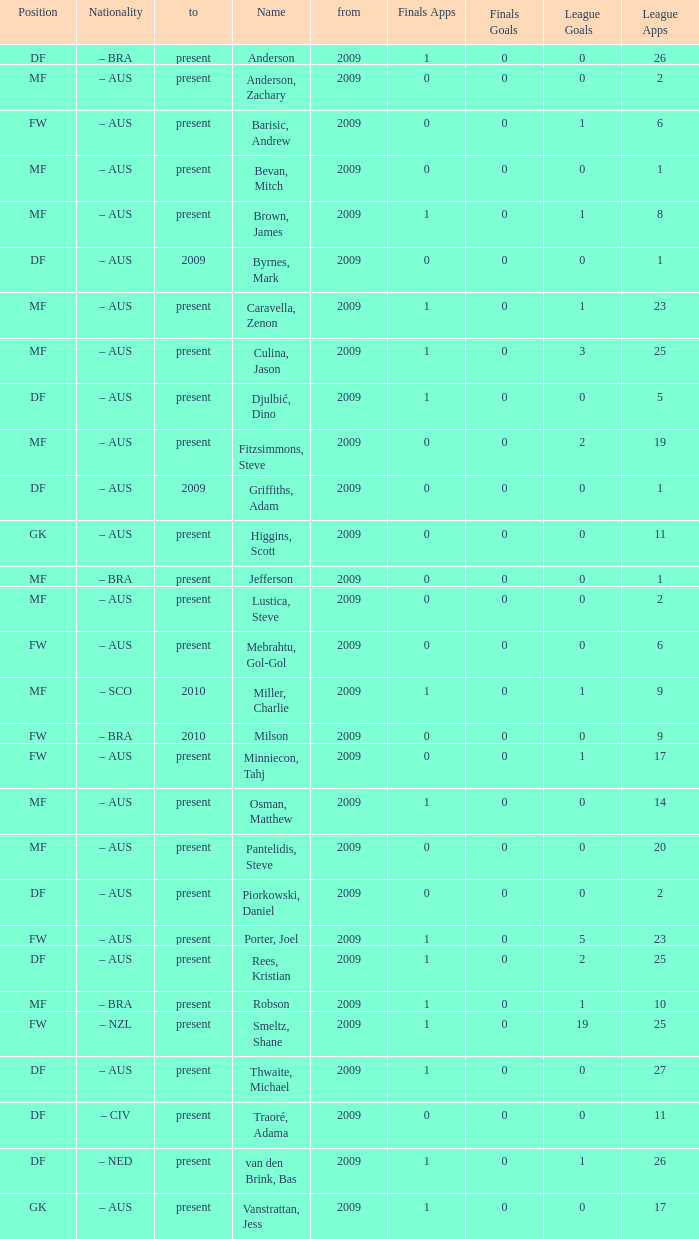Name the position for van den brink, bas DF. 